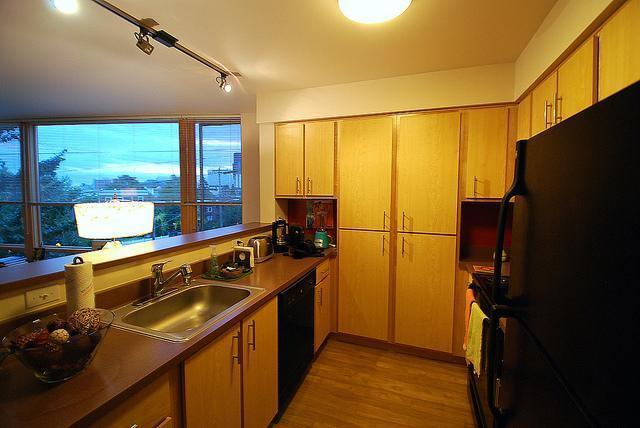How many towels are hanging from the stove?
Give a very brief answer. 2. 